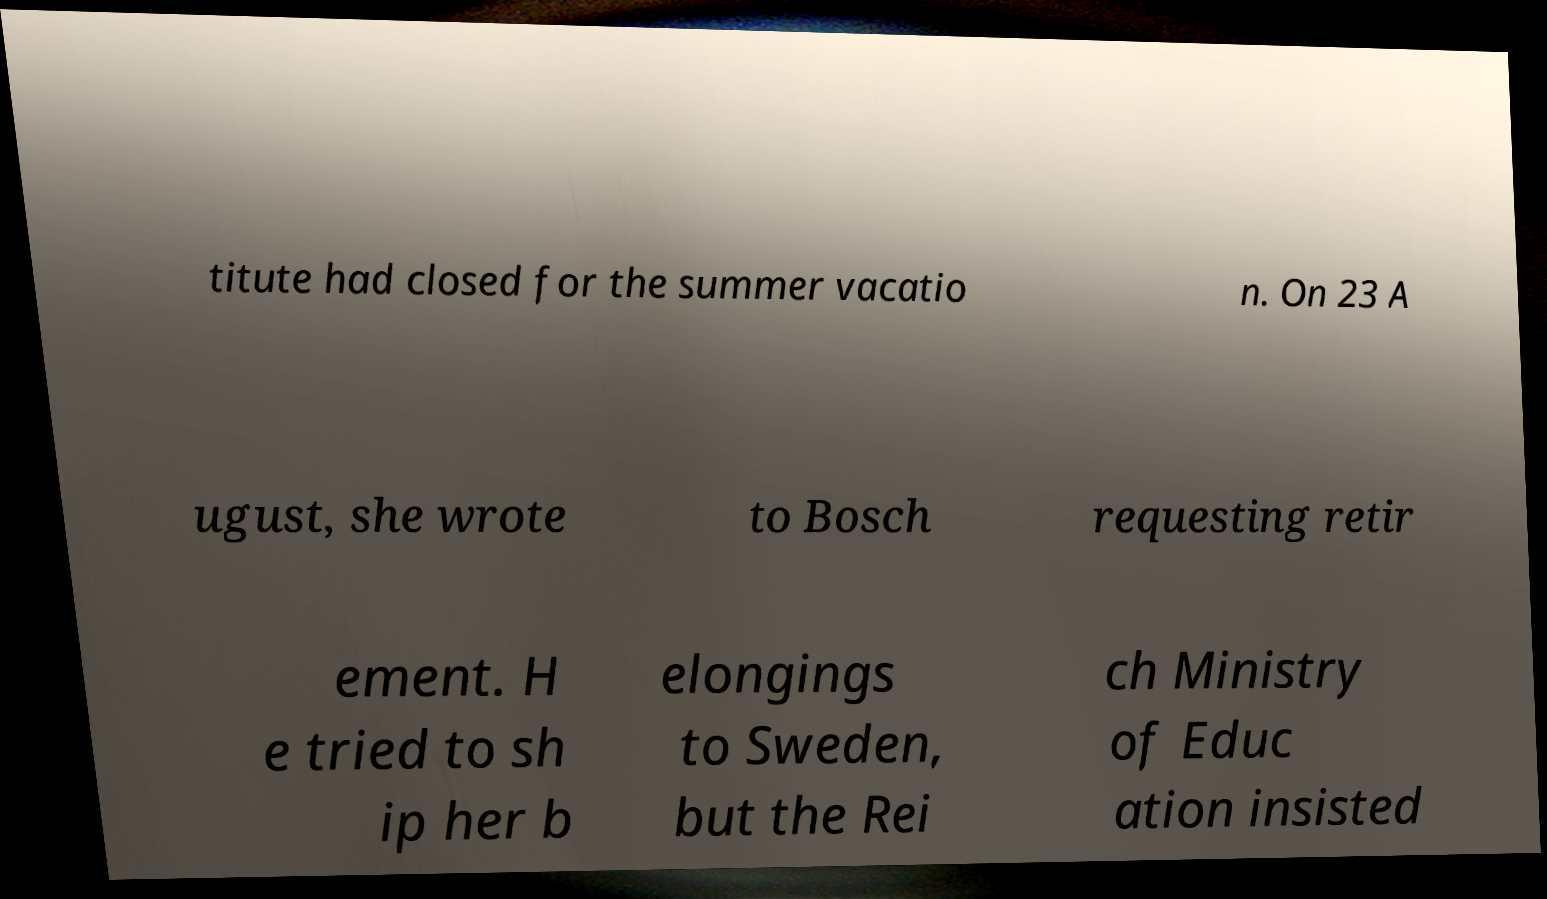Can you read and provide the text displayed in the image?This photo seems to have some interesting text. Can you extract and type it out for me? titute had closed for the summer vacatio n. On 23 A ugust, she wrote to Bosch requesting retir ement. H e tried to sh ip her b elongings to Sweden, but the Rei ch Ministry of Educ ation insisted 